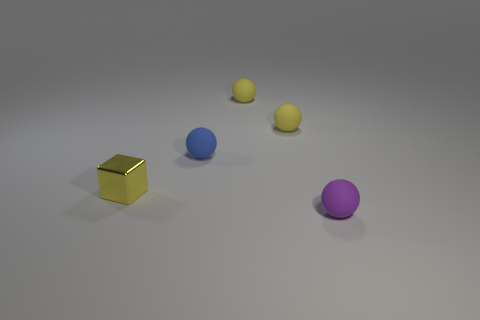Is there anything else that is made of the same material as the tiny block?
Keep it short and to the point. No. There is a small purple matte thing; what shape is it?
Give a very brief answer. Sphere. The small yellow thing that is left of the small blue rubber object that is on the right side of the metallic block is what shape?
Make the answer very short. Cube. Are the ball in front of the blue sphere and the small blue object made of the same material?
Your answer should be compact. Yes. How many purple objects are small matte things or tiny shiny objects?
Your answer should be very brief. 1. Is there a small metal object that has the same color as the small metallic cube?
Ensure brevity in your answer.  No. Are there any big gray spheres made of the same material as the blue sphere?
Make the answer very short. No. What is the shape of the object that is in front of the small blue object and on the left side of the purple matte sphere?
Your answer should be compact. Cube. How many tiny objects are either yellow balls or purple spheres?
Ensure brevity in your answer.  3. What is the small cube made of?
Provide a short and direct response. Metal. 